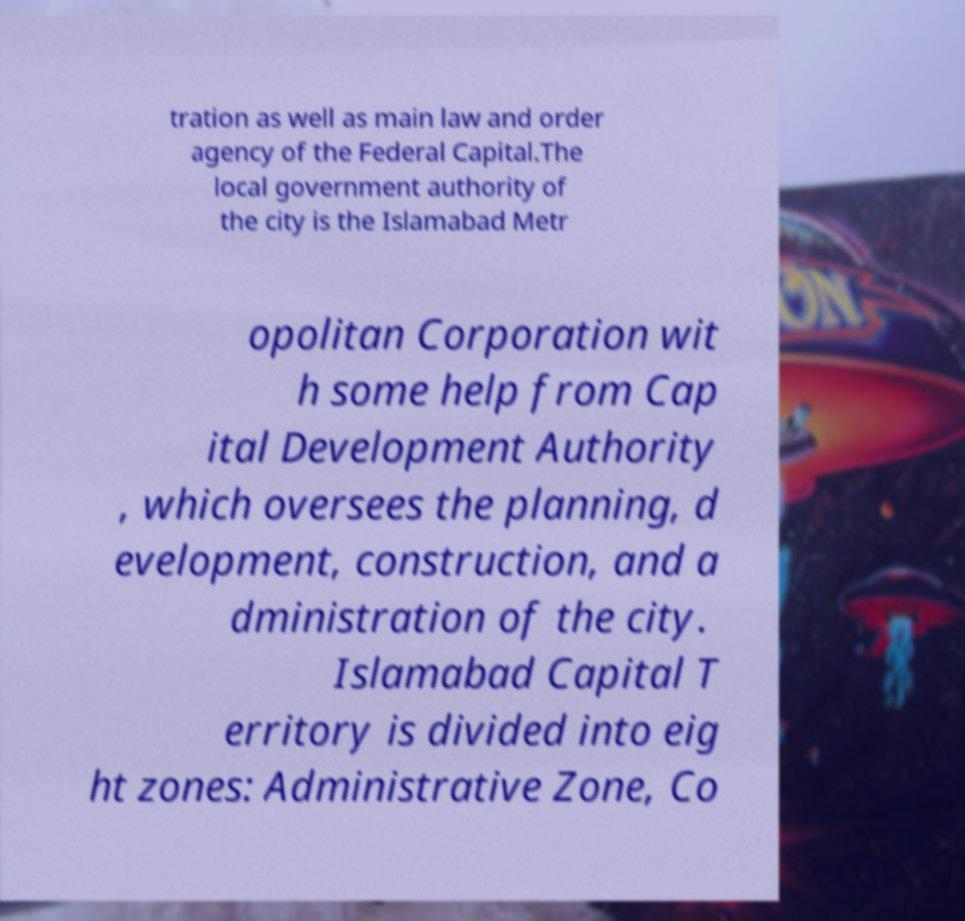For documentation purposes, I need the text within this image transcribed. Could you provide that? tration as well as main law and order agency of the Federal Capital.The local government authority of the city is the Islamabad Metr opolitan Corporation wit h some help from Cap ital Development Authority , which oversees the planning, d evelopment, construction, and a dministration of the city. Islamabad Capital T erritory is divided into eig ht zones: Administrative Zone, Co 